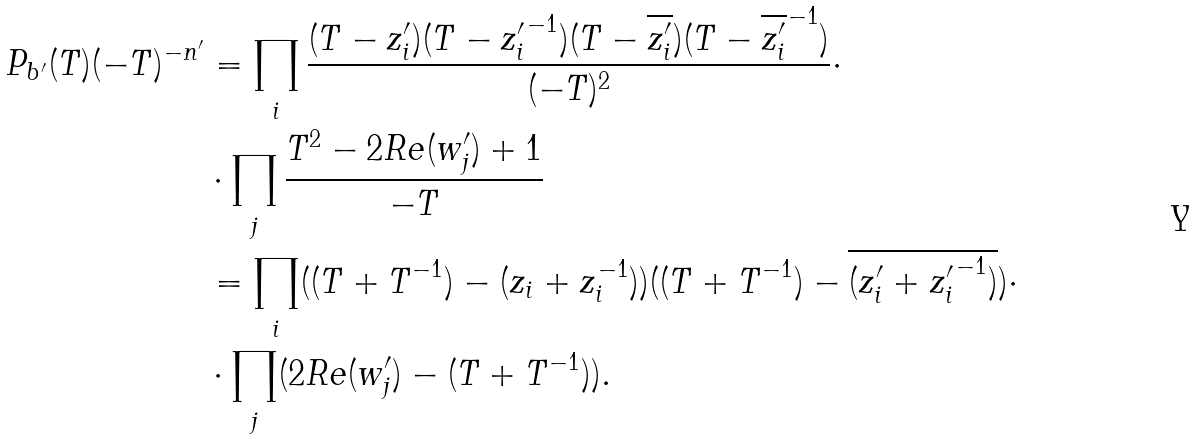Convert formula to latex. <formula><loc_0><loc_0><loc_500><loc_500>P _ { b ^ { \prime } } ( T ) ( - T ) ^ { - n ^ { \prime } } & = \prod _ { i } \frac { ( T - z ^ { \prime } _ { i } ) ( T - { z ^ { \prime } _ { i } } ^ { - 1 } ) ( T - \overline { z ^ { \prime } _ { i } } ) ( T - \overline { z ^ { \prime } _ { i } } ^ { - 1 } ) } { ( - T ) ^ { 2 } } \cdot \\ & \cdot \prod _ { j } \frac { T ^ { 2 } - 2 R e ( w ^ { \prime } _ { j } ) + 1 } { - T } \\ & = \prod _ { i } ( ( T + T ^ { - 1 } ) - ( z _ { i } + z _ { i } ^ { - 1 } ) ) ( ( T + T ^ { - 1 } ) - \overline { ( z ^ { \prime } _ { i } + { z ^ { \prime } _ { i } } ^ { - 1 } ) } ) \cdot \\ & \cdot \prod _ { j } ( 2 R e ( w ^ { \prime } _ { j } ) - ( T + T ^ { - 1 } ) ) .</formula> 